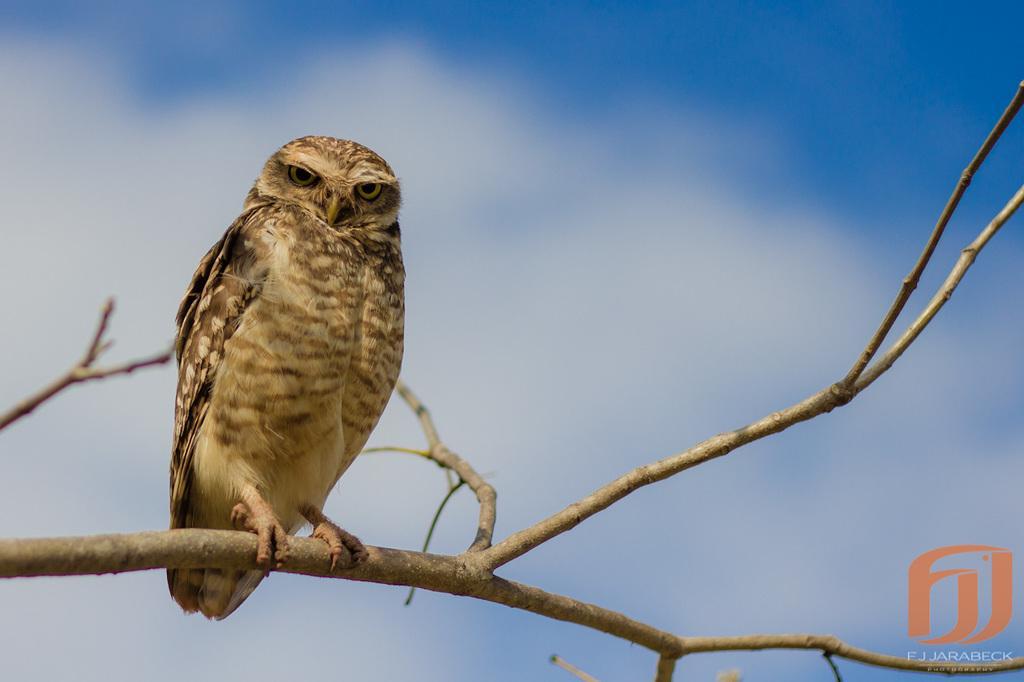Describe this image in one or two sentences. In this image we can see an owl which is on the branch of a tree and in the background of the image there is clear sky. 